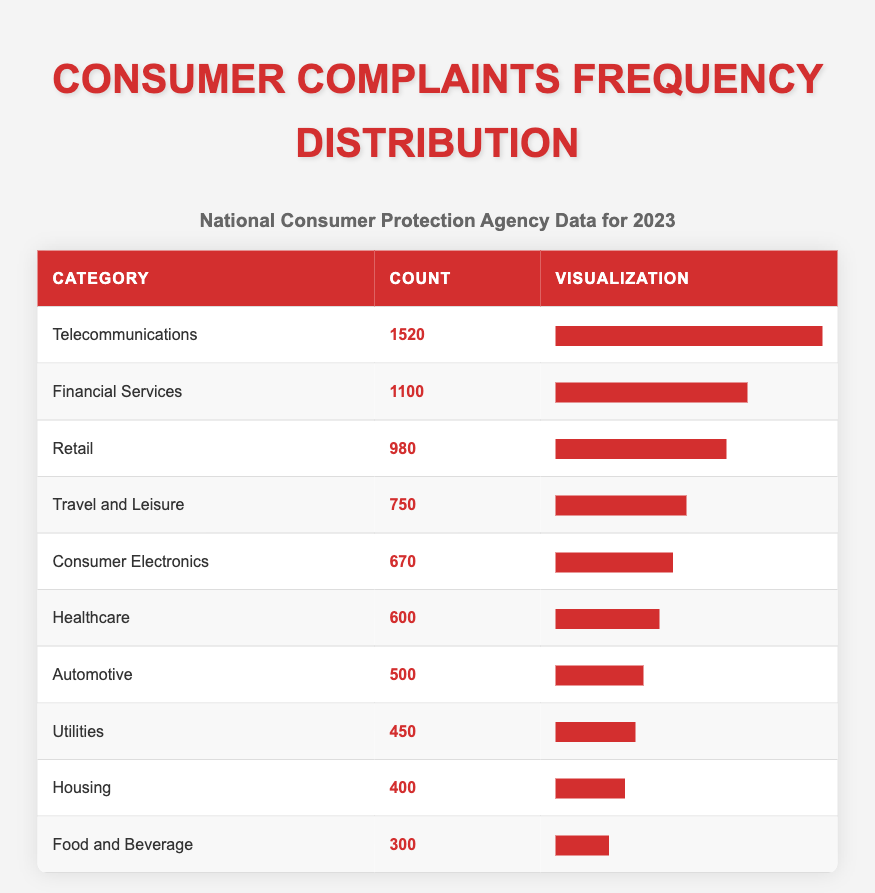What category received the highest number of consumer complaints? The table shows that the category with the highest count is Telecommunications, which received 1520 complaints.
Answer: Telecommunications How many complaints were received in the Retail category? The Retail category has a total of 980 complaints listed in the table.
Answer: 980 What is the total number of complaints received in the Financial Services and Utilities categories combined? Adding the two counts together, Financial Services received 1100 complaints, and Utilities received 450 complaints. So the total is 1100 + 450 = 1550.
Answer: 1550 Was the count of complaints in the Healthcare category greater than 500? The table shows that Healthcare received 600 complaints, which is greater than 500.
Answer: Yes What percentage of total complaints were related to Food and Beverage? First, we need to sum all complaints: 1520 + 980 + 750 + 1100 + 600 + 400 + 500 + 300 + 450 + 670 = 5470. Food and Beverage received 300 complaints. To find the percentage: (300 / 5470) * 100 = approximately 5.48%.
Answer: Approximately 5.48% 